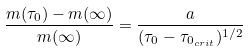<formula> <loc_0><loc_0><loc_500><loc_500>\frac { m ( \tau _ { 0 } ) - m ( \infty ) } { m ( \infty ) } = \frac { a } { ( \tau _ { 0 } - \tau _ { 0 _ { c r i t } } ) ^ { 1 / 2 } }</formula> 